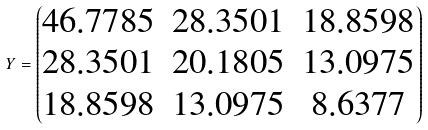Convert formula to latex. <formula><loc_0><loc_0><loc_500><loc_500>Y = \begin{pmatrix} 4 6 . 7 7 8 5 & 2 8 . 3 5 0 1 & 1 8 . 8 5 9 8 \\ 2 8 . 3 5 0 1 & 2 0 . 1 8 0 5 & 1 3 . 0 9 7 5 \\ 1 8 . 8 5 9 8 & 1 3 . 0 9 7 5 & 8 . 6 3 7 7 \\ \end{pmatrix}</formula> 